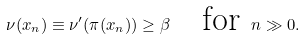Convert formula to latex. <formula><loc_0><loc_0><loc_500><loc_500>\nu ( x _ { n } ) \equiv \nu ^ { \prime } ( \pi ( x _ { n } ) ) \geq \beta \quad \text {for } n \gg 0 .</formula> 